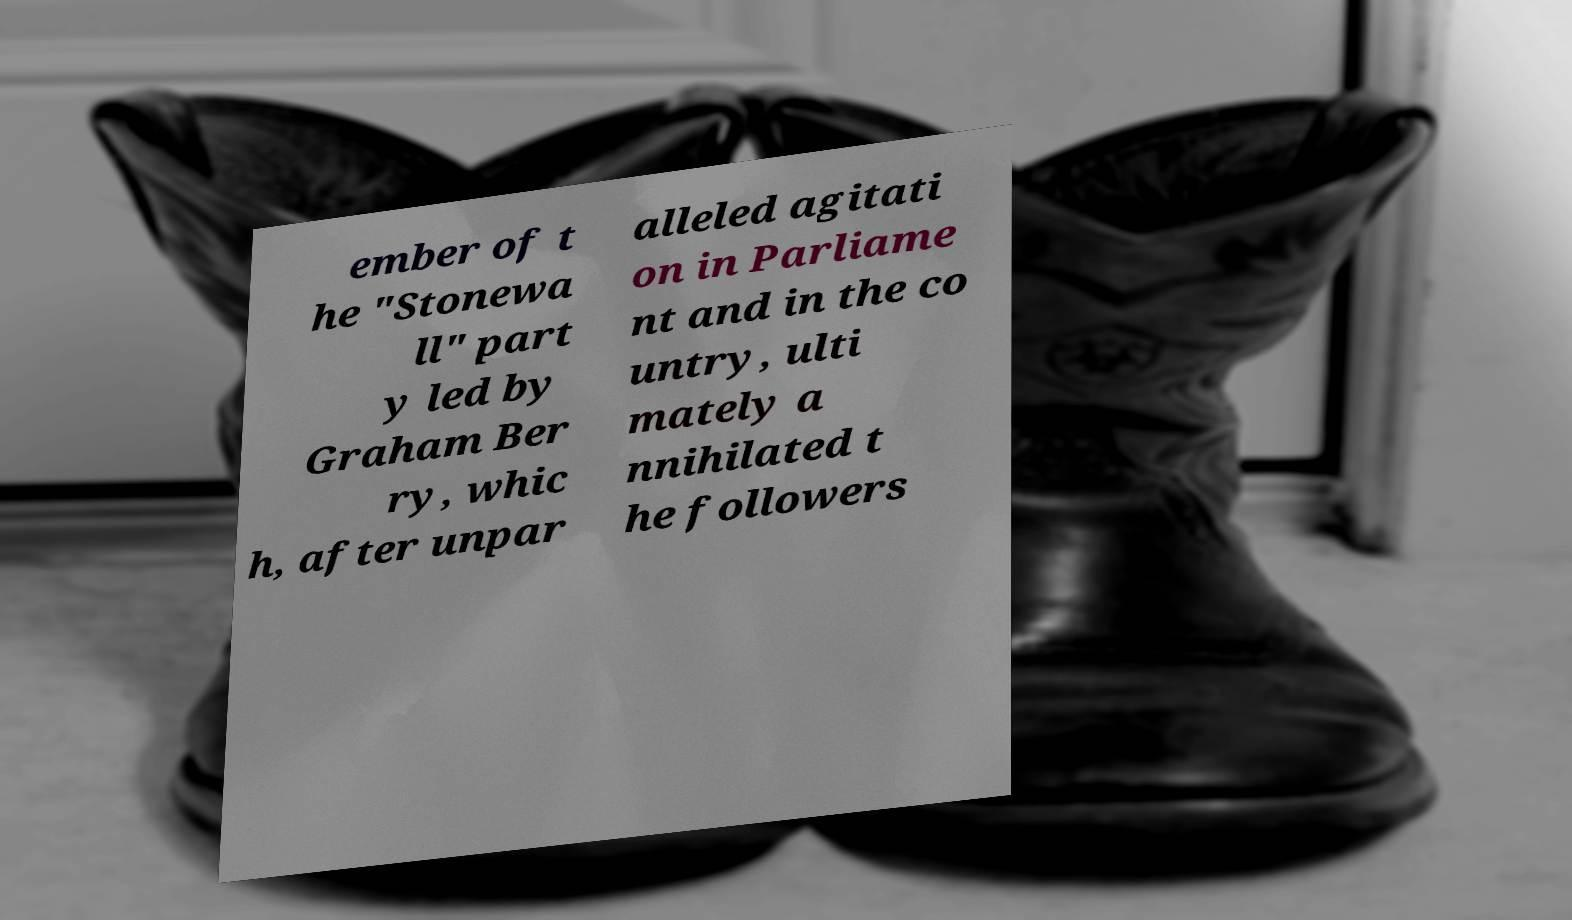Please read and relay the text visible in this image. What does it say? ember of t he "Stonewa ll" part y led by Graham Ber ry, whic h, after unpar alleled agitati on in Parliame nt and in the co untry, ulti mately a nnihilated t he followers 